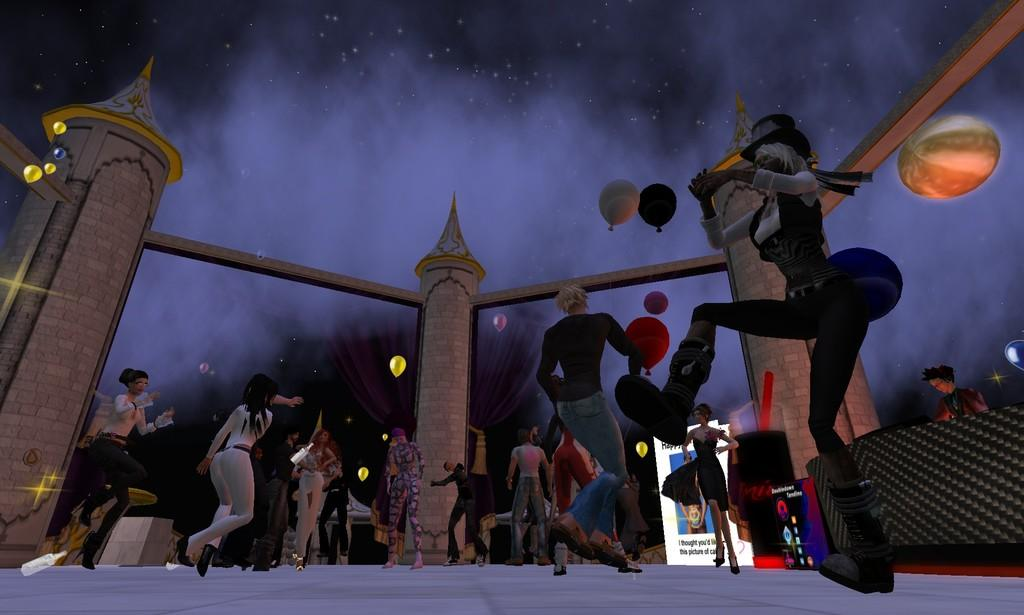Who or what can be seen in the image? There are people in the image. What objects are present in the image besides the people? There are balloons and banners in the image. What type of background is visible in the image? There is a wall in the image. What time of day is it in the image, and how does the zephyr affect the afternoon? The provided facts do not mention the time of day or the presence of a zephyr, so we cannot answer these questions based on the image. 